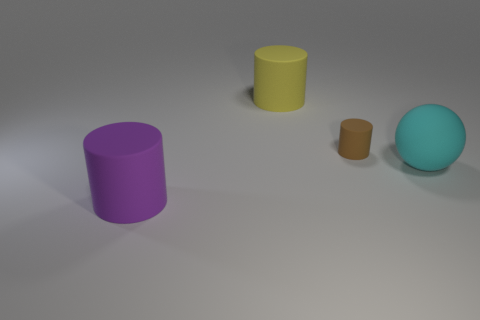Is there anything else that has the same shape as the large cyan matte thing?
Your answer should be compact. No. There is a large cyan matte sphere; are there any small matte cylinders behind it?
Your response must be concise. Yes. How big is the brown object behind the large object on the right side of the big cylinder right of the purple rubber thing?
Provide a succinct answer. Small. Is the shape of the object that is behind the brown matte object the same as the purple thing in front of the tiny cylinder?
Your answer should be very brief. Yes. What is the size of the other yellow rubber thing that is the same shape as the tiny matte object?
Provide a succinct answer. Large. How many large cyan objects are made of the same material as the small object?
Your answer should be very brief. 1. There is a large object that is in front of the thing that is on the right side of the small brown object; what shape is it?
Your answer should be very brief. Cylinder. What is the shape of the object behind the tiny brown matte cylinder?
Keep it short and to the point. Cylinder. How many other matte spheres have the same color as the large matte ball?
Your answer should be compact. 0. The small matte cylinder has what color?
Give a very brief answer. Brown. 